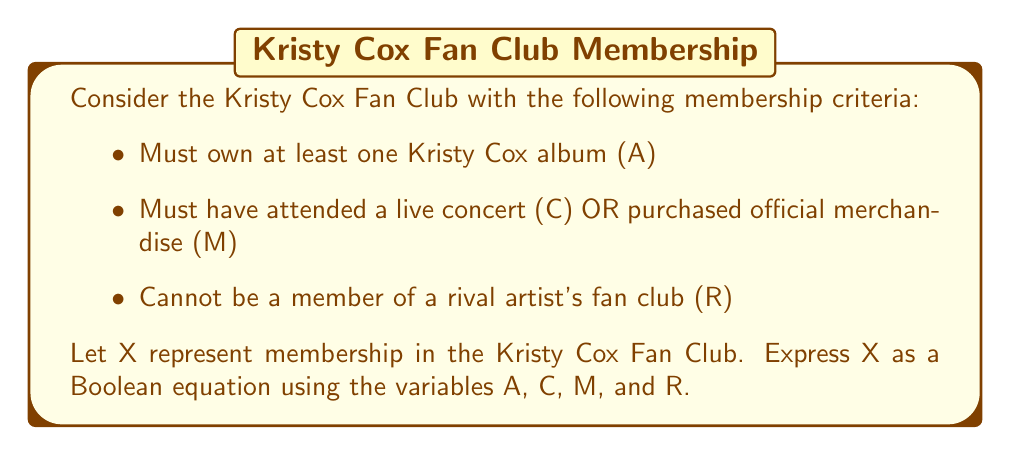Could you help me with this problem? To solve this problem, we'll translate each criteria into Boolean algebra and combine them:

1. Must own at least one Kristy Cox album: This is represented by A

2. Must have attended a live concert OR purchased official merchandise: This is represented by $(C + M)$, where '+' denotes the OR operation

3. Cannot be a member of a rival artist's fan club: This is represented by $\overline{R}$, where the bar denotes the NOT operation

To be a member of the fan club, a person must satisfy all these criteria. In Boolean algebra, the AND operation is represented by multiplication. Therefore, we combine these conditions as follows:

$$X = A \cdot (C + M) \cdot \overline{R}$$

This equation can be further simplified using the distributive property:

$$X = (A \cdot C \cdot \overline{R}) + (A \cdot M \cdot \overline{R})$$

This final form shows that to be a member of the Kristy Cox Fan Club, one must either:
- Own an album AND attend a concert AND not be in a rival fan club, OR
- Own an album AND purchase merchandise AND not be in a rival fan club
Answer: $X = A \cdot (C + M) \cdot \overline{R}$ 